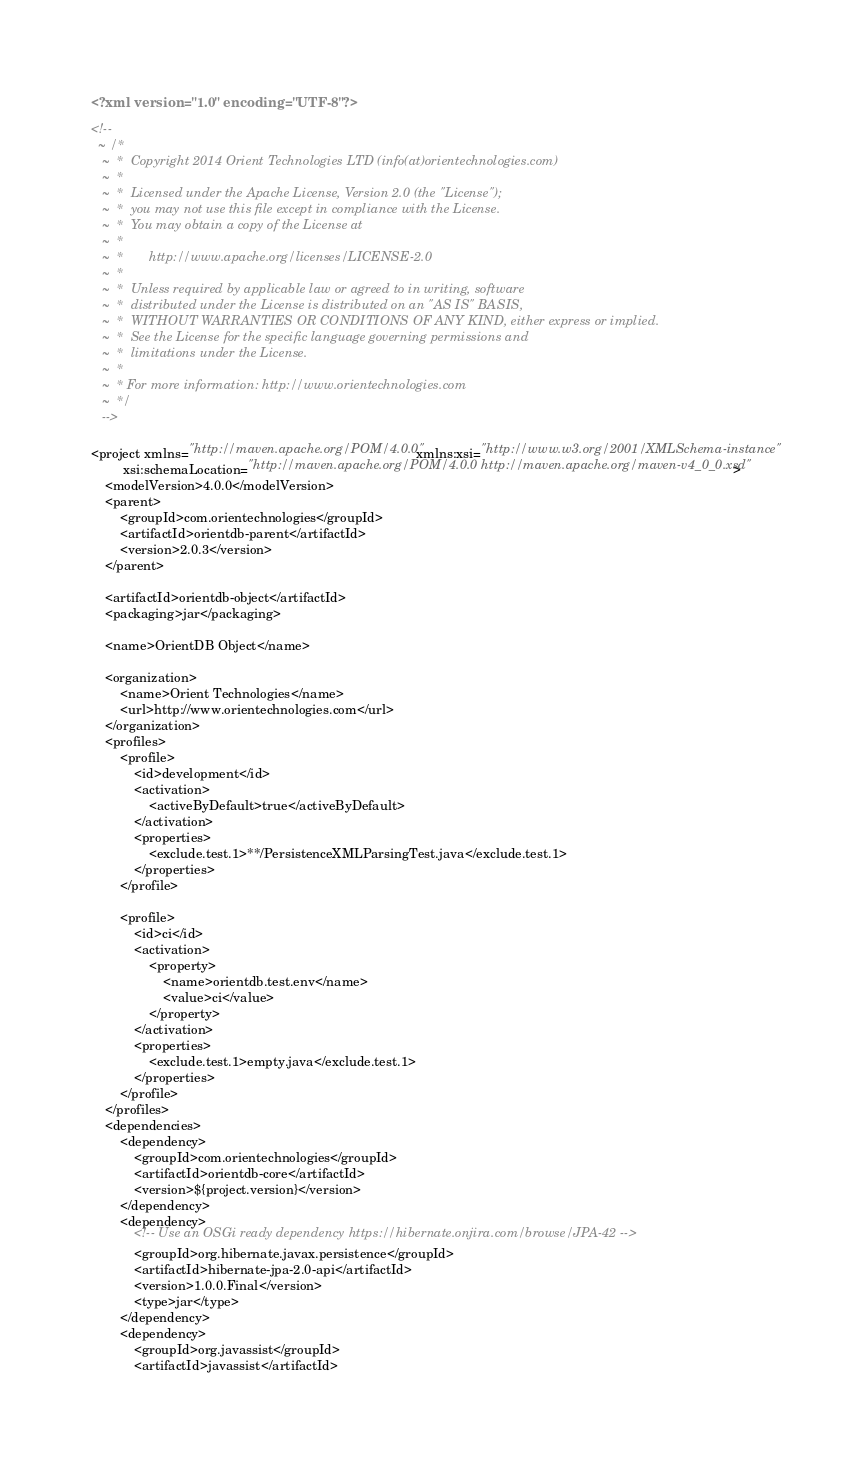<code> <loc_0><loc_0><loc_500><loc_500><_XML_><?xml version="1.0" encoding="UTF-8"?>

<!--
  ~ /*
   ~  *  Copyright 2014 Orient Technologies LTD (info(at)orientechnologies.com)
   ~  *
   ~  *  Licensed under the Apache License, Version 2.0 (the "License");
   ~  *  you may not use this file except in compliance with the License.
   ~  *  You may obtain a copy of the License at
   ~  *
   ~  *       http://www.apache.org/licenses/LICENSE-2.0
   ~  *
   ~  *  Unless required by applicable law or agreed to in writing, software
   ~  *  distributed under the License is distributed on an "AS IS" BASIS,
   ~  *  WITHOUT WARRANTIES OR CONDITIONS OF ANY KIND, either express or implied.
   ~  *  See the License for the specific language governing permissions and
   ~  *  limitations under the License.
   ~  *
   ~  * For more information: http://www.orientechnologies.com
   ~  */
   -->

<project xmlns="http://maven.apache.org/POM/4.0.0" xmlns:xsi="http://www.w3.org/2001/XMLSchema-instance"
         xsi:schemaLocation="http://maven.apache.org/POM/4.0.0 http://maven.apache.org/maven-v4_0_0.xsd">
    <modelVersion>4.0.0</modelVersion>
    <parent>
        <groupId>com.orientechnologies</groupId>
        <artifactId>orientdb-parent</artifactId>
        <version>2.0.3</version>
    </parent>

    <artifactId>orientdb-object</artifactId>
    <packaging>jar</packaging>

    <name>OrientDB Object</name>

    <organization>
        <name>Orient Technologies</name>
        <url>http://www.orientechnologies.com</url>
    </organization>
    <profiles>
        <profile>
            <id>development</id>
            <activation>
                <activeByDefault>true</activeByDefault>
            </activation>
            <properties>
                <exclude.test.1>**/PersistenceXMLParsingTest.java</exclude.test.1>
            </properties>
        </profile>

        <profile>
            <id>ci</id>
            <activation>
                <property>
                    <name>orientdb.test.env</name>
                    <value>ci</value>
                </property>
            </activation>
            <properties>
                <exclude.test.1>empty.java</exclude.test.1>
            </properties>
        </profile>
    </profiles>
    <dependencies>
        <dependency>
            <groupId>com.orientechnologies</groupId>
            <artifactId>orientdb-core</artifactId>
            <version>${project.version}</version>
        </dependency>
        <dependency>
            <!-- Use an OSGi ready dependency https://hibernate.onjira.com/browse/JPA-42 -->
            <groupId>org.hibernate.javax.persistence</groupId>
            <artifactId>hibernate-jpa-2.0-api</artifactId>
            <version>1.0.0.Final</version>
            <type>jar</type>
        </dependency>
        <dependency>
            <groupId>org.javassist</groupId>
            <artifactId>javassist</artifactId></code> 